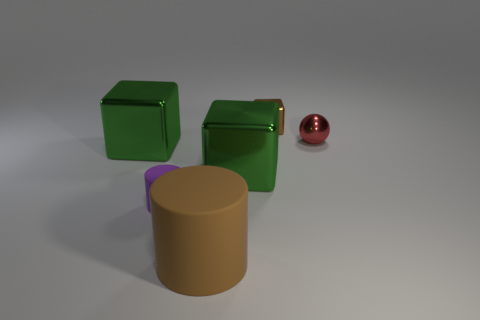Add 1 gray spheres. How many objects exist? 7 Subtract all spheres. How many objects are left? 5 Subtract 1 green cubes. How many objects are left? 5 Subtract all metallic blocks. Subtract all large things. How many objects are left? 0 Add 2 brown metal cubes. How many brown metal cubes are left? 3 Add 4 purple things. How many purple things exist? 5 